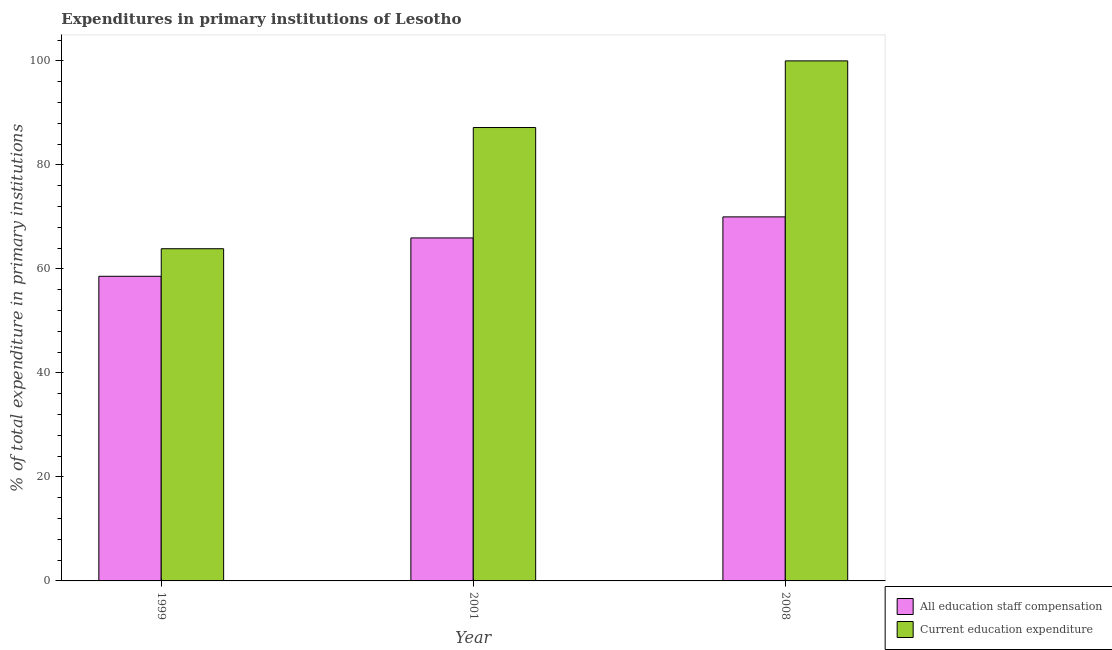Are the number of bars per tick equal to the number of legend labels?
Your response must be concise. Yes. How many bars are there on the 2nd tick from the left?
Provide a short and direct response. 2. How many bars are there on the 3rd tick from the right?
Ensure brevity in your answer.  2. What is the label of the 2nd group of bars from the left?
Ensure brevity in your answer.  2001. Across all years, what is the minimum expenditure in staff compensation?
Your answer should be very brief. 58.58. In which year was the expenditure in staff compensation maximum?
Your answer should be compact. 2008. What is the total expenditure in staff compensation in the graph?
Offer a very short reply. 194.53. What is the difference between the expenditure in staff compensation in 1999 and that in 2008?
Offer a very short reply. -11.43. What is the difference between the expenditure in education in 2001 and the expenditure in staff compensation in 2008?
Your response must be concise. -12.81. What is the average expenditure in education per year?
Provide a short and direct response. 83.69. In the year 2008, what is the difference between the expenditure in staff compensation and expenditure in education?
Make the answer very short. 0. In how many years, is the expenditure in staff compensation greater than 32 %?
Ensure brevity in your answer.  3. What is the ratio of the expenditure in education in 1999 to that in 2001?
Give a very brief answer. 0.73. Is the difference between the expenditure in education in 2001 and 2008 greater than the difference between the expenditure in staff compensation in 2001 and 2008?
Keep it short and to the point. No. What is the difference between the highest and the second highest expenditure in education?
Offer a very short reply. 12.81. What is the difference between the highest and the lowest expenditure in education?
Your answer should be very brief. 36.12. What does the 1st bar from the left in 2008 represents?
Keep it short and to the point. All education staff compensation. What does the 2nd bar from the right in 2008 represents?
Make the answer very short. All education staff compensation. How many bars are there?
Offer a terse response. 6. How many years are there in the graph?
Your answer should be very brief. 3. Are the values on the major ticks of Y-axis written in scientific E-notation?
Your response must be concise. No. Does the graph contain grids?
Make the answer very short. No. How many legend labels are there?
Your answer should be very brief. 2. What is the title of the graph?
Your response must be concise. Expenditures in primary institutions of Lesotho. Does "Measles" appear as one of the legend labels in the graph?
Give a very brief answer. No. What is the label or title of the Y-axis?
Make the answer very short. % of total expenditure in primary institutions. What is the % of total expenditure in primary institutions of All education staff compensation in 1999?
Your response must be concise. 58.58. What is the % of total expenditure in primary institutions of Current education expenditure in 1999?
Offer a very short reply. 63.88. What is the % of total expenditure in primary institutions in All education staff compensation in 2001?
Your response must be concise. 65.95. What is the % of total expenditure in primary institutions of Current education expenditure in 2001?
Offer a very short reply. 87.19. What is the % of total expenditure in primary institutions of All education staff compensation in 2008?
Provide a short and direct response. 70. Across all years, what is the maximum % of total expenditure in primary institutions in All education staff compensation?
Ensure brevity in your answer.  70. Across all years, what is the maximum % of total expenditure in primary institutions in Current education expenditure?
Ensure brevity in your answer.  100. Across all years, what is the minimum % of total expenditure in primary institutions in All education staff compensation?
Give a very brief answer. 58.58. Across all years, what is the minimum % of total expenditure in primary institutions in Current education expenditure?
Give a very brief answer. 63.88. What is the total % of total expenditure in primary institutions of All education staff compensation in the graph?
Your answer should be very brief. 194.53. What is the total % of total expenditure in primary institutions of Current education expenditure in the graph?
Provide a succinct answer. 251.06. What is the difference between the % of total expenditure in primary institutions of All education staff compensation in 1999 and that in 2001?
Give a very brief answer. -7.38. What is the difference between the % of total expenditure in primary institutions in Current education expenditure in 1999 and that in 2001?
Your answer should be very brief. -23.31. What is the difference between the % of total expenditure in primary institutions of All education staff compensation in 1999 and that in 2008?
Your answer should be very brief. -11.43. What is the difference between the % of total expenditure in primary institutions in Current education expenditure in 1999 and that in 2008?
Provide a succinct answer. -36.12. What is the difference between the % of total expenditure in primary institutions in All education staff compensation in 2001 and that in 2008?
Your answer should be compact. -4.05. What is the difference between the % of total expenditure in primary institutions in Current education expenditure in 2001 and that in 2008?
Your response must be concise. -12.81. What is the difference between the % of total expenditure in primary institutions in All education staff compensation in 1999 and the % of total expenditure in primary institutions in Current education expenditure in 2001?
Your answer should be compact. -28.61. What is the difference between the % of total expenditure in primary institutions in All education staff compensation in 1999 and the % of total expenditure in primary institutions in Current education expenditure in 2008?
Make the answer very short. -41.42. What is the difference between the % of total expenditure in primary institutions in All education staff compensation in 2001 and the % of total expenditure in primary institutions in Current education expenditure in 2008?
Your response must be concise. -34.05. What is the average % of total expenditure in primary institutions in All education staff compensation per year?
Your answer should be compact. 64.84. What is the average % of total expenditure in primary institutions in Current education expenditure per year?
Your answer should be very brief. 83.69. In the year 1999, what is the difference between the % of total expenditure in primary institutions in All education staff compensation and % of total expenditure in primary institutions in Current education expenditure?
Offer a terse response. -5.3. In the year 2001, what is the difference between the % of total expenditure in primary institutions of All education staff compensation and % of total expenditure in primary institutions of Current education expenditure?
Keep it short and to the point. -21.23. In the year 2008, what is the difference between the % of total expenditure in primary institutions of All education staff compensation and % of total expenditure in primary institutions of Current education expenditure?
Give a very brief answer. -30. What is the ratio of the % of total expenditure in primary institutions in All education staff compensation in 1999 to that in 2001?
Provide a short and direct response. 0.89. What is the ratio of the % of total expenditure in primary institutions of Current education expenditure in 1999 to that in 2001?
Provide a succinct answer. 0.73. What is the ratio of the % of total expenditure in primary institutions in All education staff compensation in 1999 to that in 2008?
Ensure brevity in your answer.  0.84. What is the ratio of the % of total expenditure in primary institutions of Current education expenditure in 1999 to that in 2008?
Provide a succinct answer. 0.64. What is the ratio of the % of total expenditure in primary institutions in All education staff compensation in 2001 to that in 2008?
Your answer should be compact. 0.94. What is the ratio of the % of total expenditure in primary institutions of Current education expenditure in 2001 to that in 2008?
Provide a short and direct response. 0.87. What is the difference between the highest and the second highest % of total expenditure in primary institutions of All education staff compensation?
Ensure brevity in your answer.  4.05. What is the difference between the highest and the second highest % of total expenditure in primary institutions of Current education expenditure?
Offer a terse response. 12.81. What is the difference between the highest and the lowest % of total expenditure in primary institutions in All education staff compensation?
Your answer should be compact. 11.43. What is the difference between the highest and the lowest % of total expenditure in primary institutions in Current education expenditure?
Give a very brief answer. 36.12. 